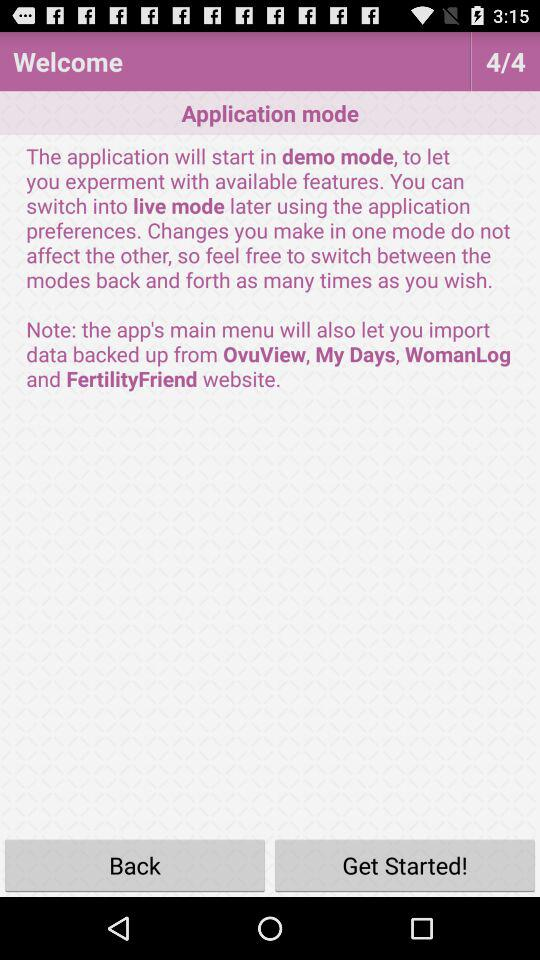What are the different types of modes?
When the provided information is insufficient, respond with <no answer>. <no answer> 